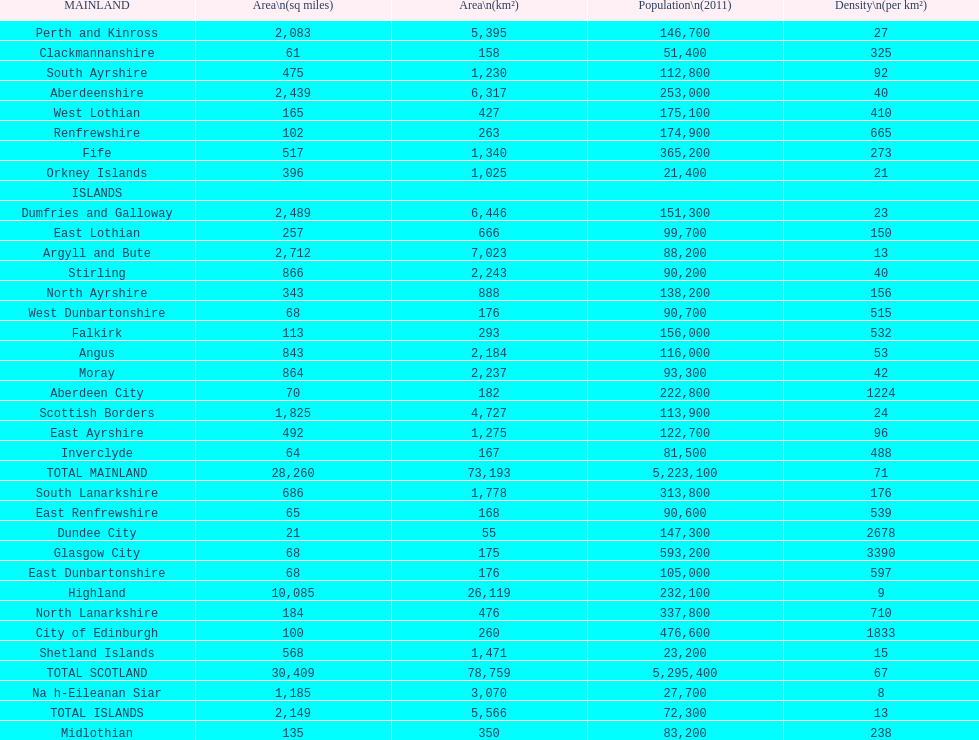What is the number of people living in angus in 2011? 116,000. 